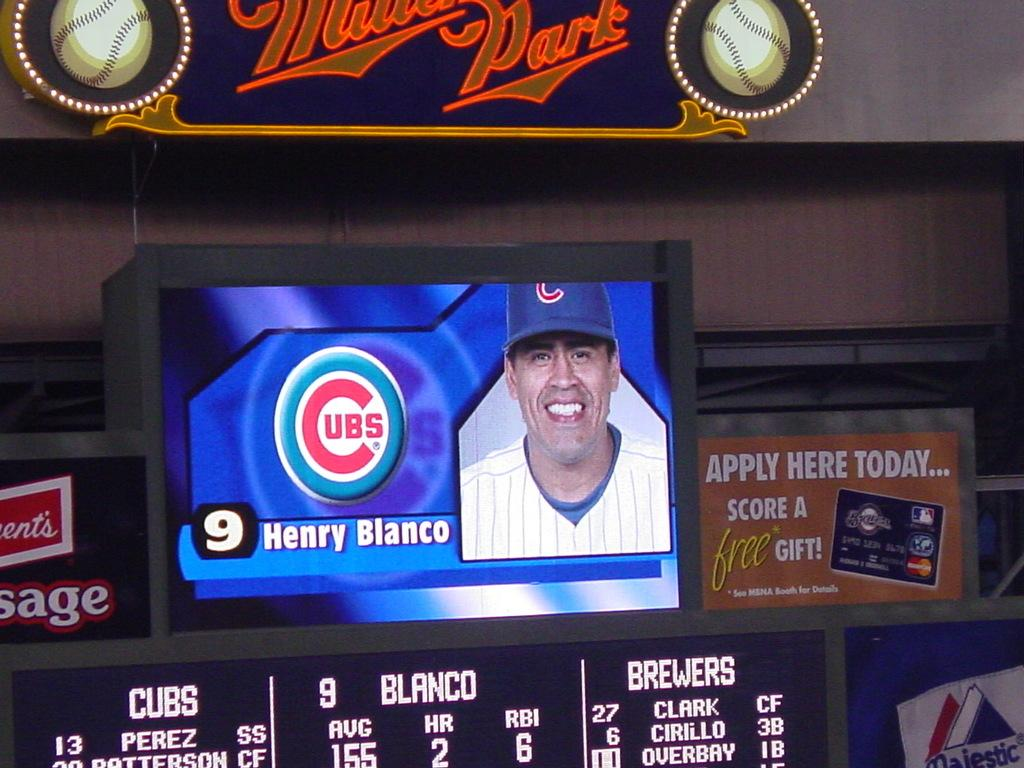<image>
Render a clear and concise summary of the photo. The player pictured on the screen is called henry Blanco. 